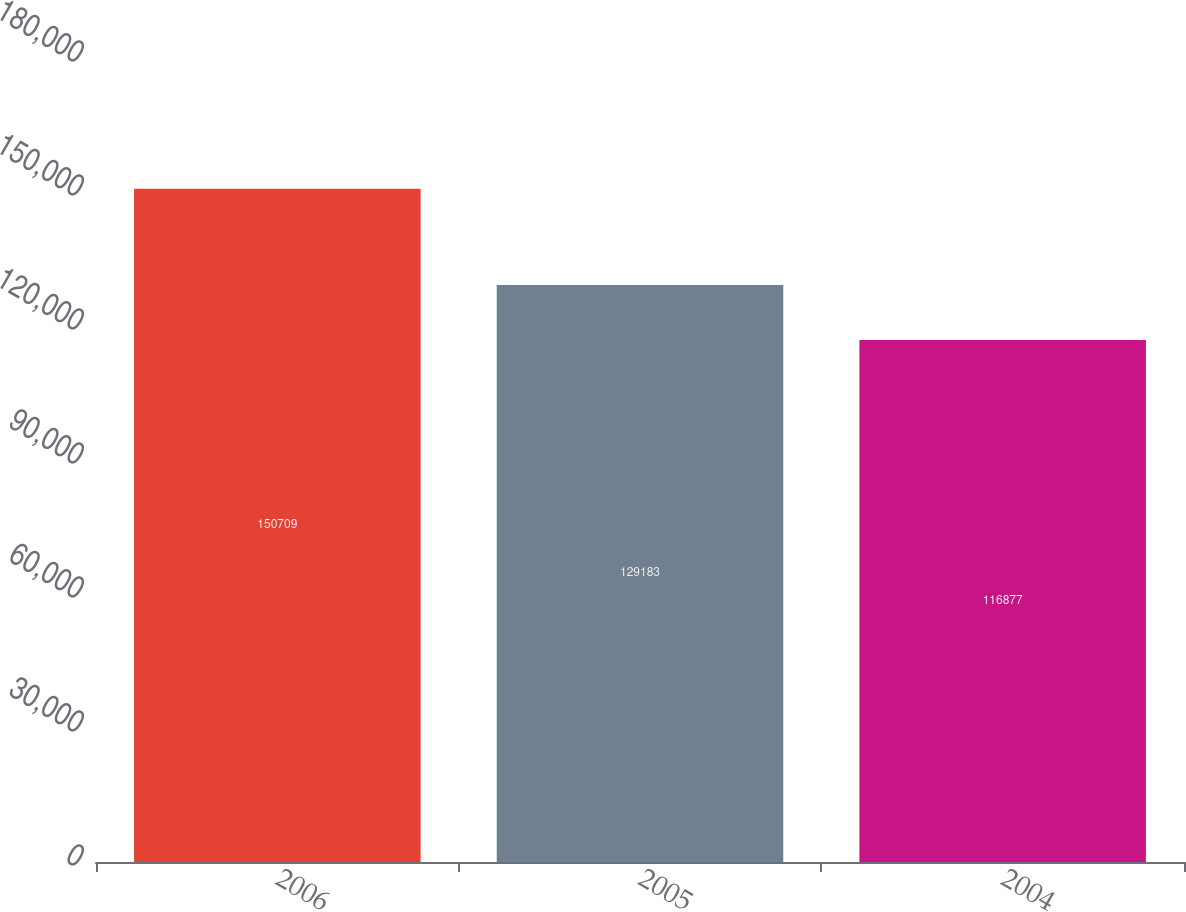Convert chart to OTSL. <chart><loc_0><loc_0><loc_500><loc_500><bar_chart><fcel>2006<fcel>2005<fcel>2004<nl><fcel>150709<fcel>129183<fcel>116877<nl></chart> 